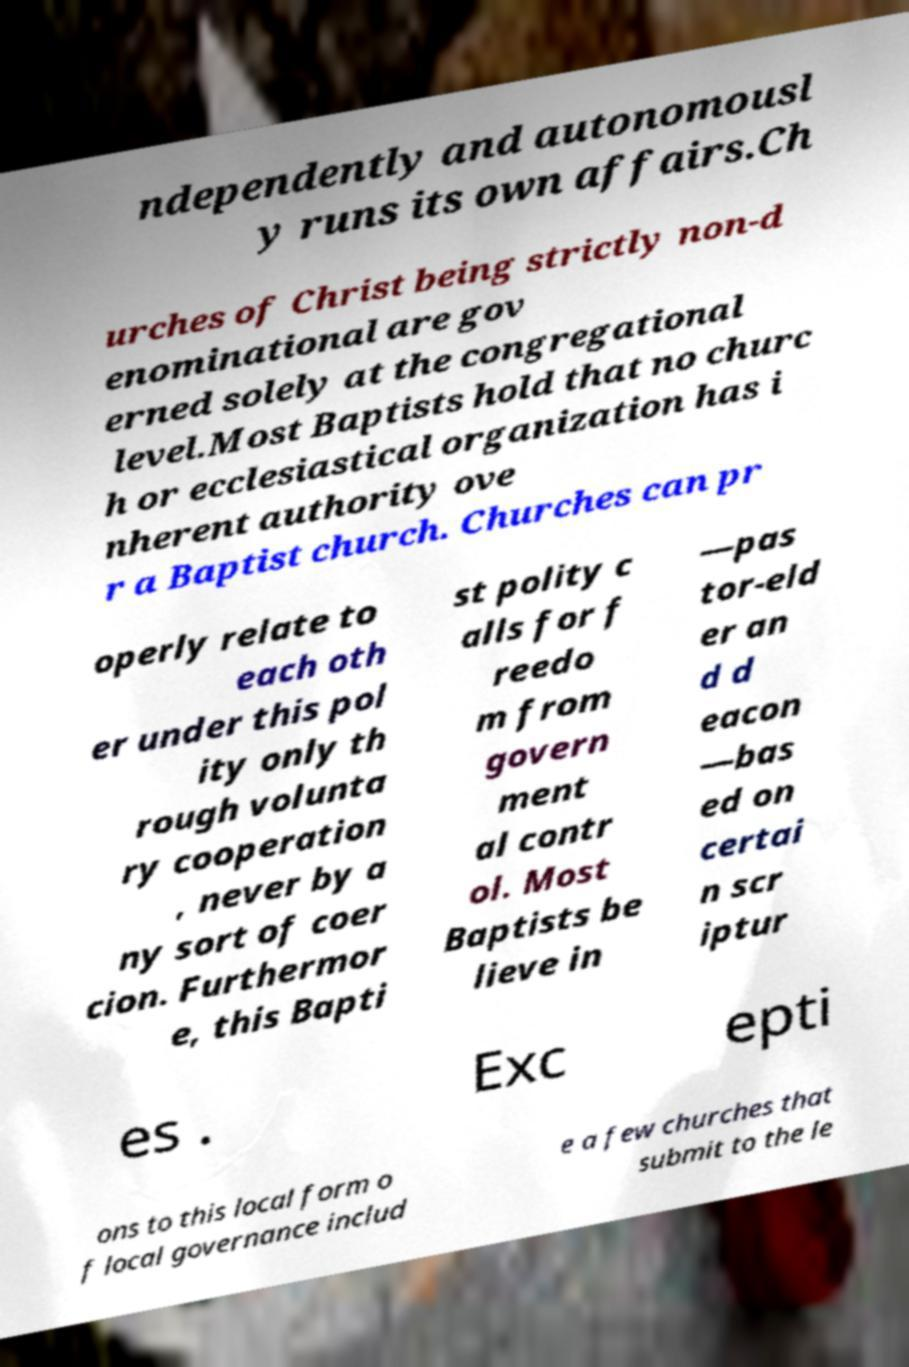What messages or text are displayed in this image? I need them in a readable, typed format. ndependently and autonomousl y runs its own affairs.Ch urches of Christ being strictly non-d enominational are gov erned solely at the congregational level.Most Baptists hold that no churc h or ecclesiastical organization has i nherent authority ove r a Baptist church. Churches can pr operly relate to each oth er under this pol ity only th rough volunta ry cooperation , never by a ny sort of coer cion. Furthermor e, this Bapti st polity c alls for f reedo m from govern ment al contr ol. Most Baptists be lieve in —pas tor-eld er an d d eacon —bas ed on certai n scr iptur es . Exc epti ons to this local form o f local governance includ e a few churches that submit to the le 